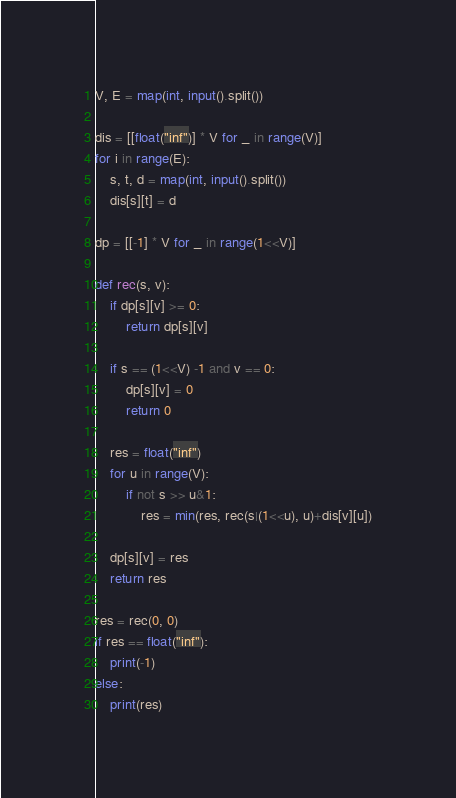Convert code to text. <code><loc_0><loc_0><loc_500><loc_500><_Python_>V, E = map(int, input().split())

dis = [[float("inf")] * V for _ in range(V)]
for i in range(E):
	s, t, d = map(int, input().split())
	dis[s][t] = d

dp = [[-1] * V for _ in range(1<<V)]

def rec(s, v):
	if dp[s][v] >= 0:
		return dp[s][v]

	if s == (1<<V) -1 and v == 0:
		dp[s][v] = 0
		return 0
	
	res = float("inf")
	for u in range(V):
		if not s >> u&1:
			res = min(res, rec(s|(1<<u), u)+dis[v][u])
	
	dp[s][v] = res
	return res

res = rec(0, 0)
if res == float("inf"):
	print(-1)
else:
	print(res)

</code> 